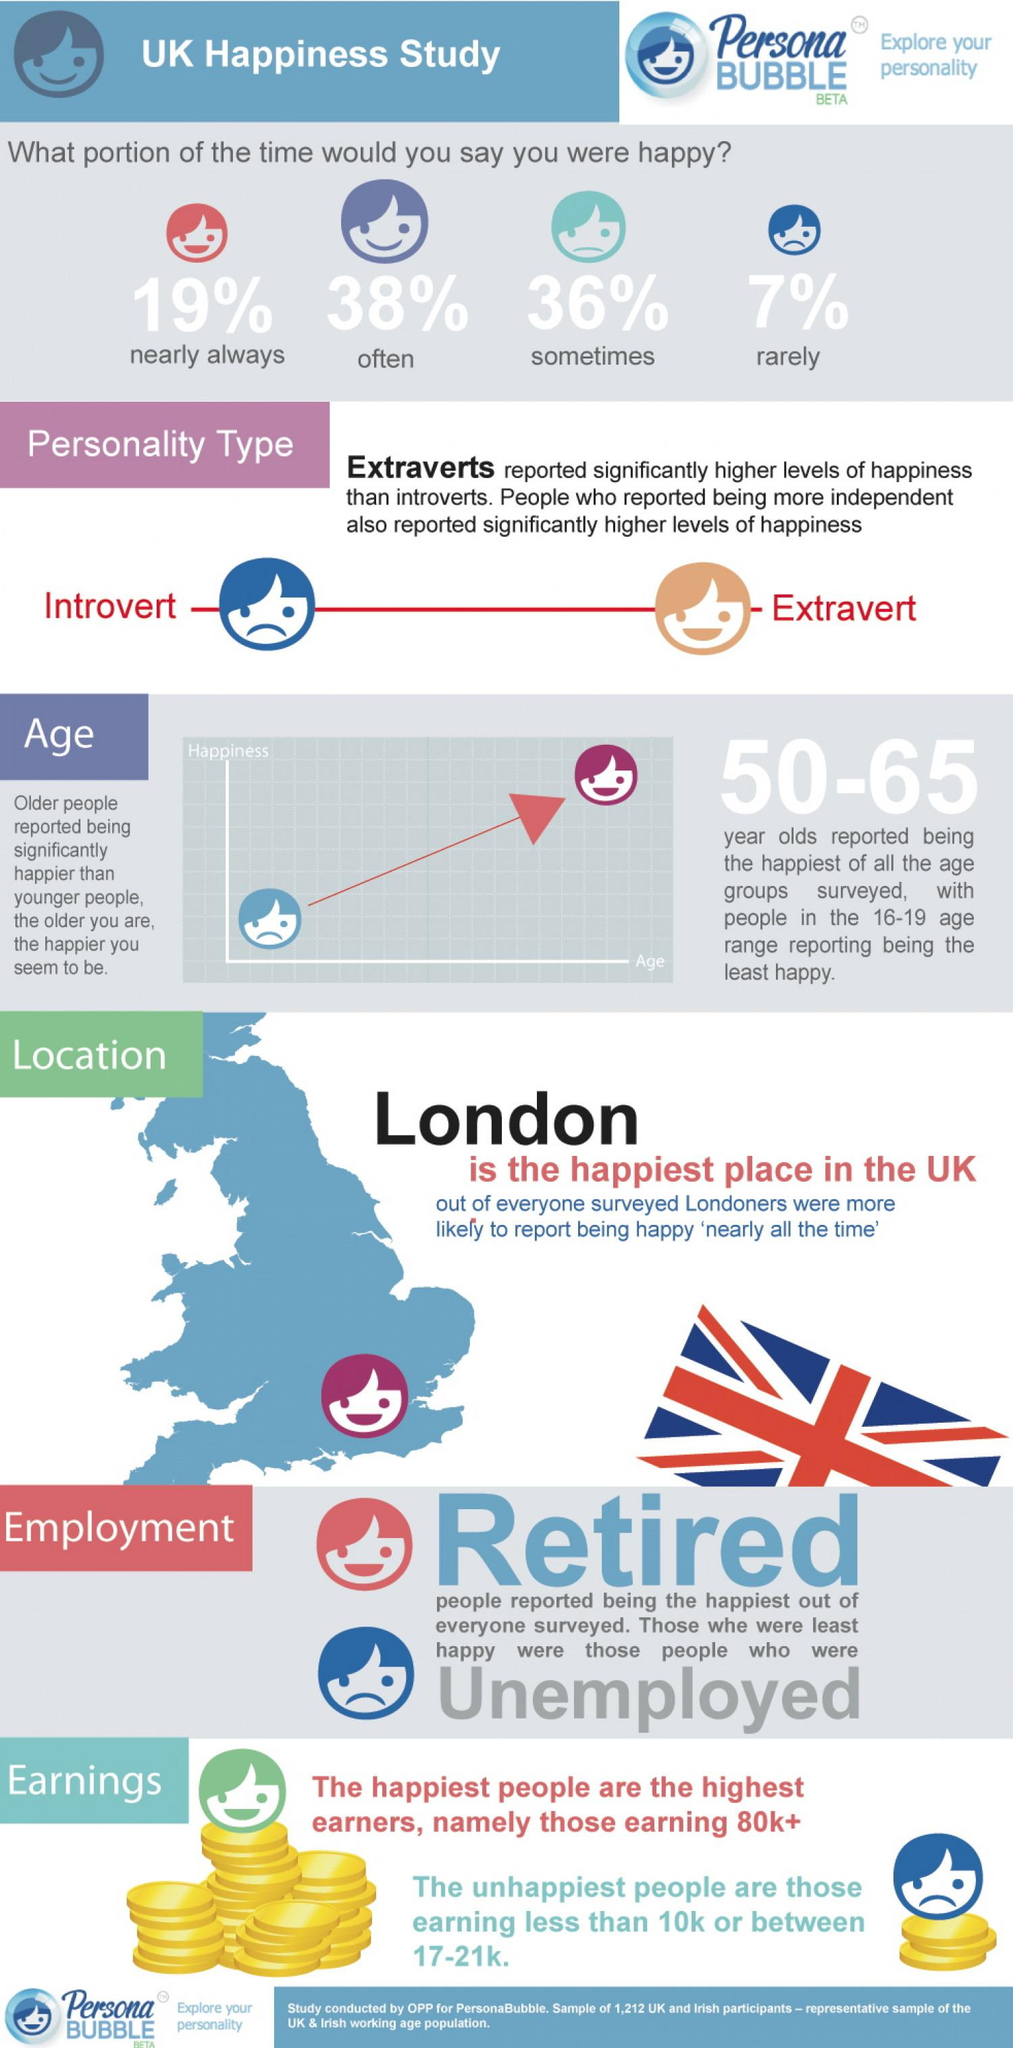Highlight a few significant elements in this photo. The color of the coins is yellow. From an employment perspective, the unemployed category was the least happy. It is estimated that 57% of people believe that they are often or nearly always happy. The age group of 50-65 is generally considered to be the happiest. As you age, your happiness is likely to increase, according to research. 